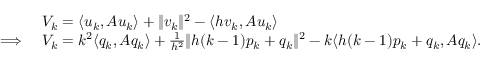<formula> <loc_0><loc_0><loc_500><loc_500>\begin{array} { r l } & { V _ { k } = \langle u _ { k } , A u _ { k } \rangle + \| v _ { k } \| ^ { 2 } - \langle h v _ { k } , A u _ { k } \rangle } \\ { \Longrightarrow \ } & { V _ { k } = k ^ { 2 } \langle q _ { k } , A q _ { k } \rangle + \frac { 1 } { h ^ { 2 } } \| h ( k - 1 ) p _ { k } + q _ { k } \| ^ { 2 } - k \langle h ( k - 1 ) p _ { k } + q _ { k } , A q _ { k } \rangle . } \end{array}</formula> 